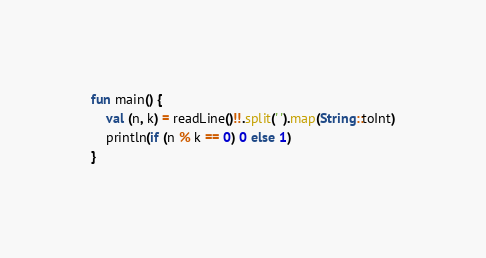Convert code to text. <code><loc_0><loc_0><loc_500><loc_500><_Kotlin_>fun main() {
    val (n, k) = readLine()!!.split(' ').map(String::toInt)
    println(if (n % k == 0) 0 else 1)
}</code> 